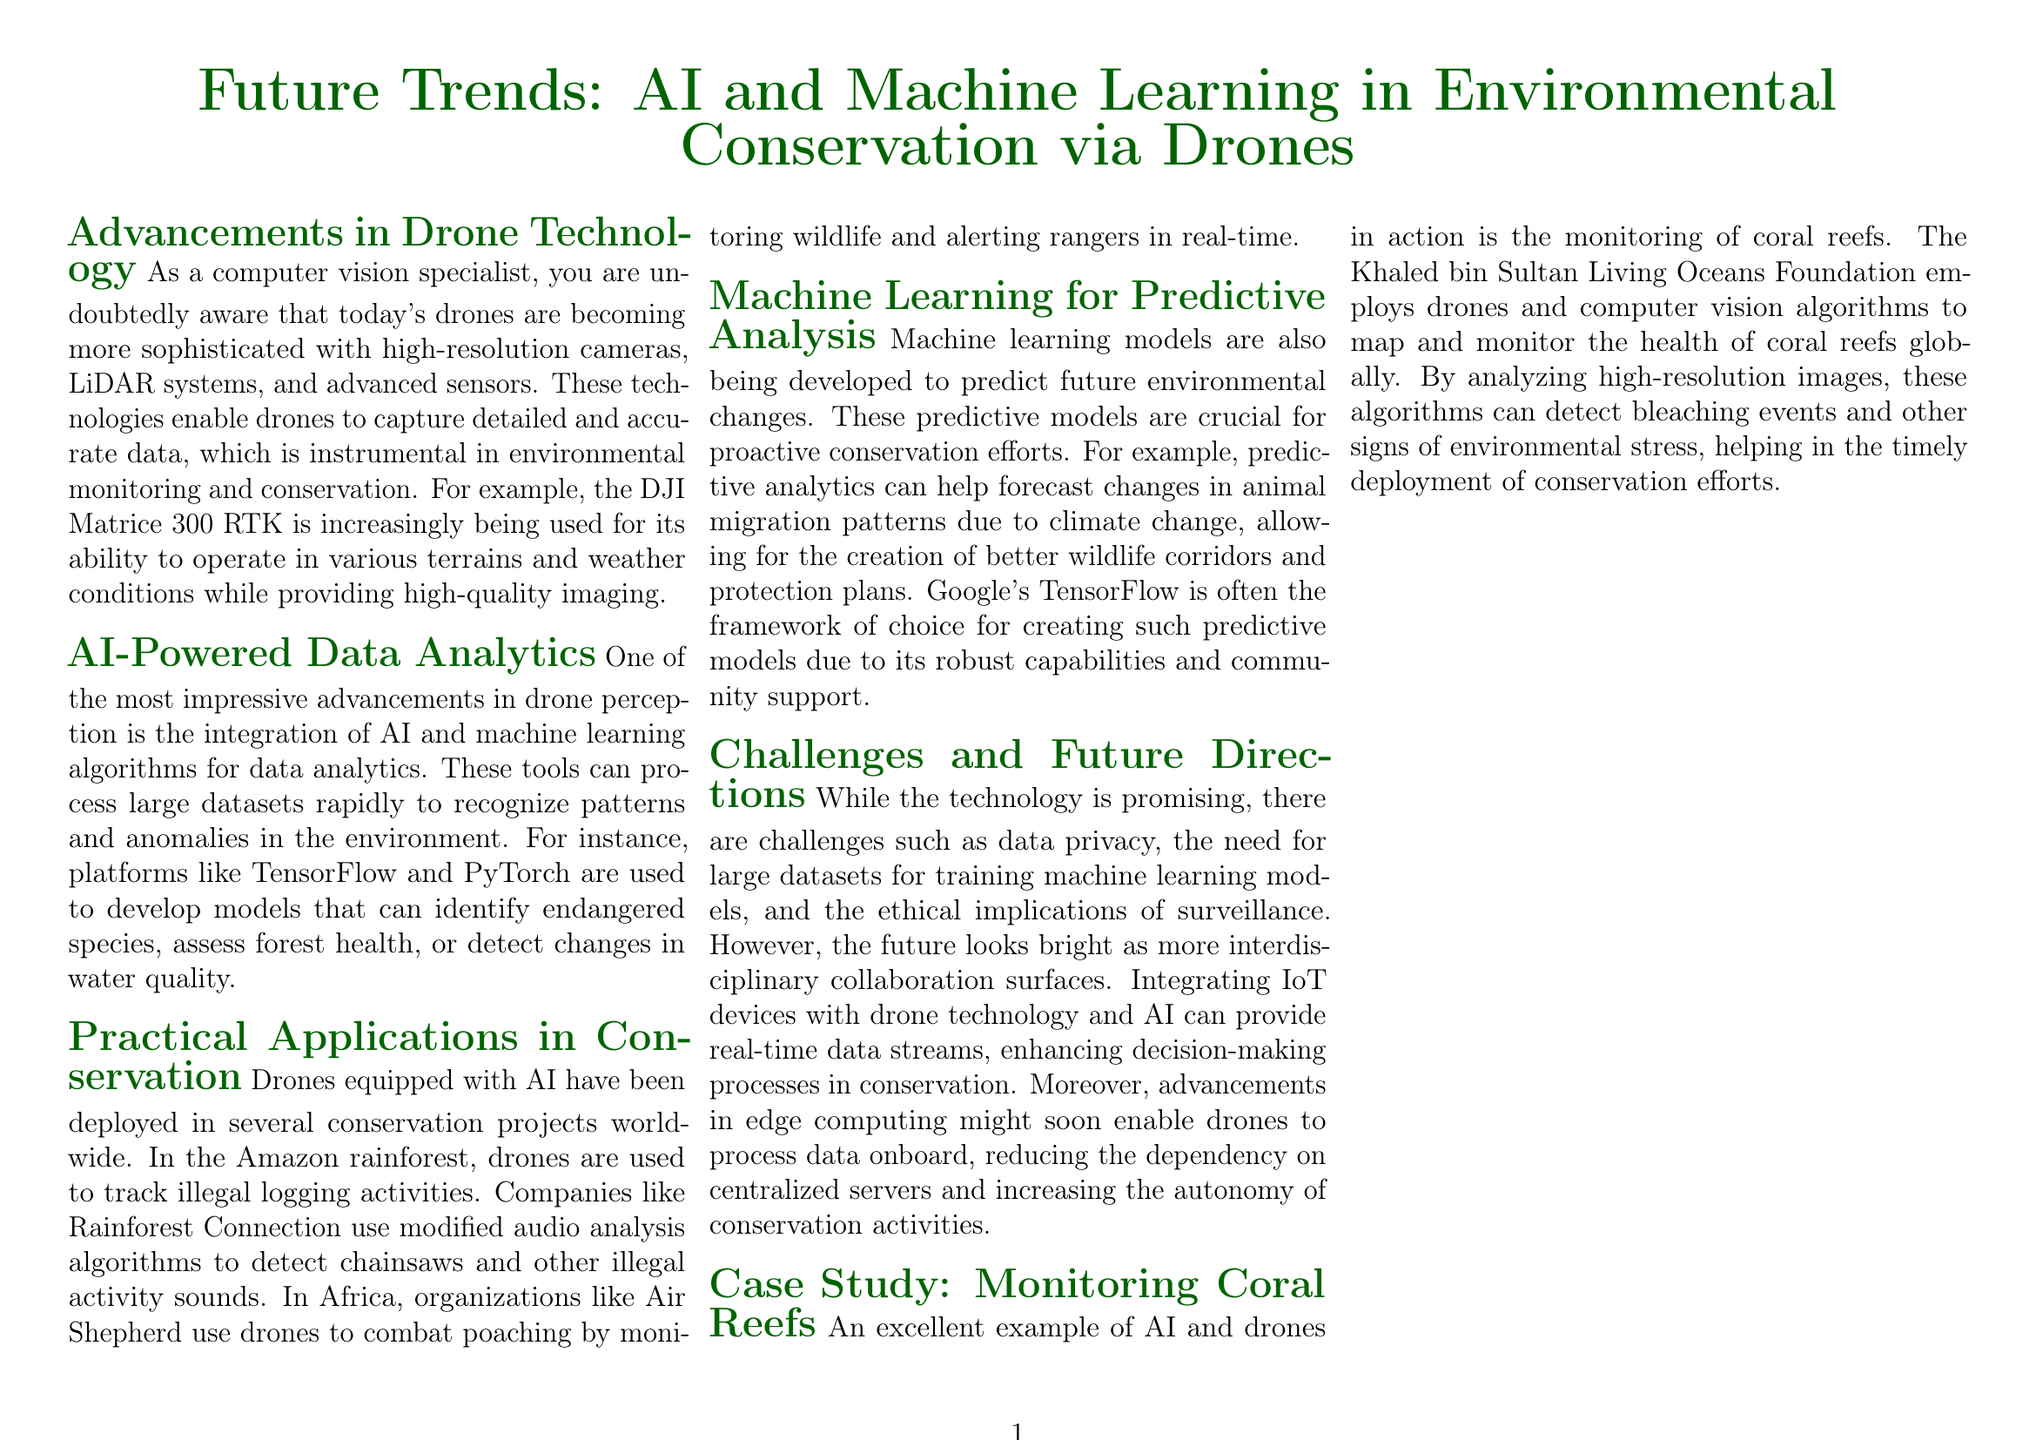what is the title of the document? The title is prominently displayed at the center of the document, stating the focus of the content.
Answer: Future Trends: AI and Machine Learning in Environmental Conservation via Drones which drone model is mentioned for its capabilities in monitoring? The DJI Matrice 300 RTK is highlighted due to its versatility and imaging quality.
Answer: DJI Matrice 300 RTK which AI frameworks are mentioned for developing models? The document lists platforms used in AI-powered data analytics specifically in drone applications.
Answer: TensorFlow and PyTorch what is the practical application of drones in the Amazon rainforest? There is a specific example provided regarding drone use for conservation efforts in a major rainforest.
Answer: Track illegal logging activities what ethical challenge is mentioned in relation to drone usage? This challenge is a significant concern associated with the deployment of drones for monitoring and surveillance purposes.
Answer: Data privacy what type of analysis is being developed to help with conservation efforts? This type of analysis is crucial for predicting environmental changes and facilitating proactive measures.
Answer: Predictive analysis which organization uses drones to monitor coral reefs? An organization is specifically named for its efforts in mapping and monitoring coral reef health.
Answer: Khaled bin Sultan Living Oceans Foundation what future technology integration is suggested in the document? The document discusses a combination of technologies that could enhance real-time data collection and analysis in conservation.
Answer: IoT devices and drone technology what is the primary benefit mentioned for machine learning in conservation? The document highlights an important aspect of machine learning's role in ensuring effective conservation strategies.
Answer: Predict future environmental changes 